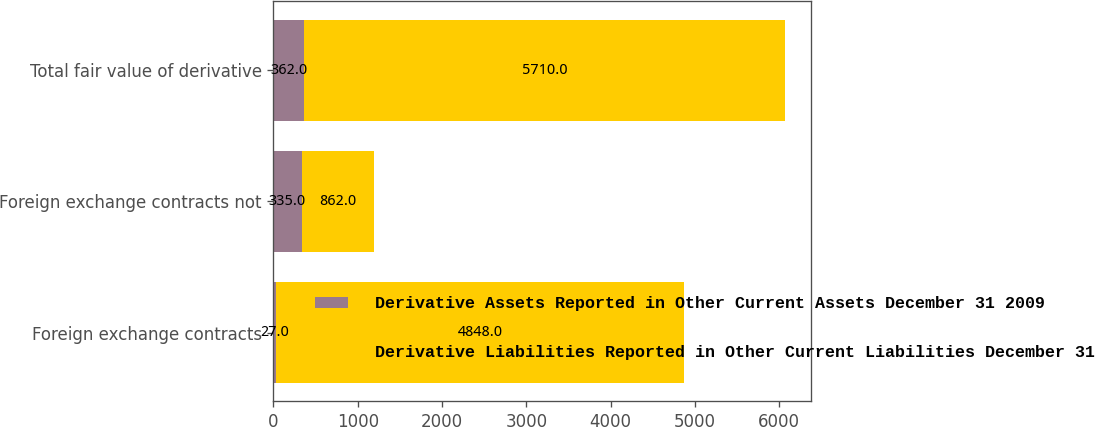Convert chart to OTSL. <chart><loc_0><loc_0><loc_500><loc_500><stacked_bar_chart><ecel><fcel>Foreign exchange contracts<fcel>Foreign exchange contracts not<fcel>Total fair value of derivative<nl><fcel>Derivative Assets Reported in Other Current Assets December 31 2009<fcel>27<fcel>335<fcel>362<nl><fcel>Derivative Liabilities Reported in Other Current Liabilities December 31 2009<fcel>4848<fcel>862<fcel>5710<nl></chart> 